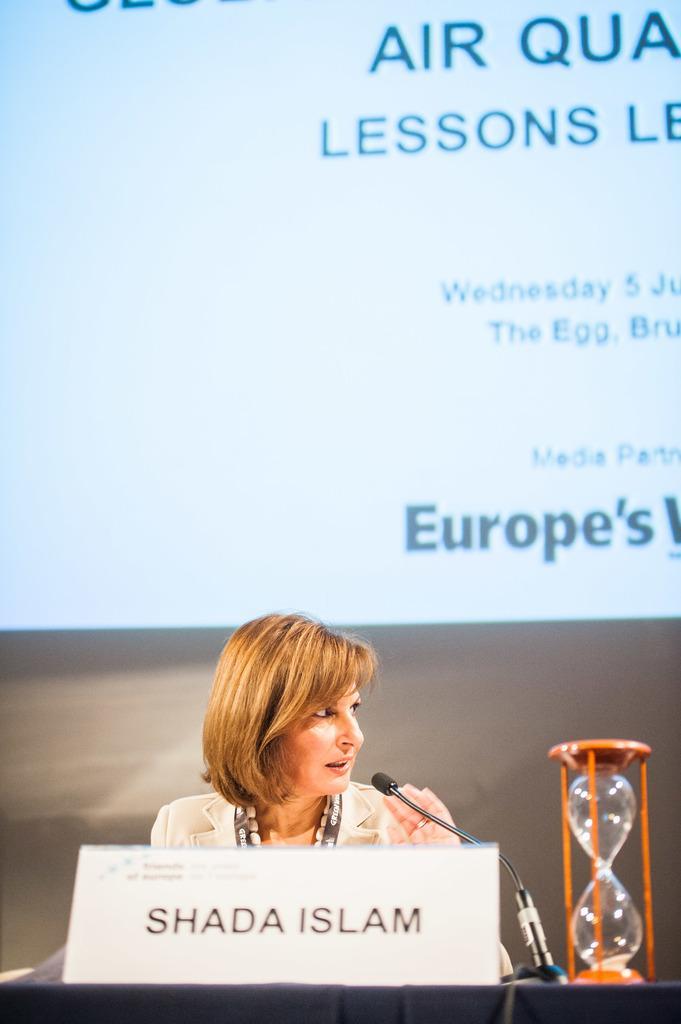Describe this image in one or two sentences. There is a lady who is sitting in the center of the image and there is a name plate, mic and sand timer in front of her, it seems like a projector screen in the background area. 